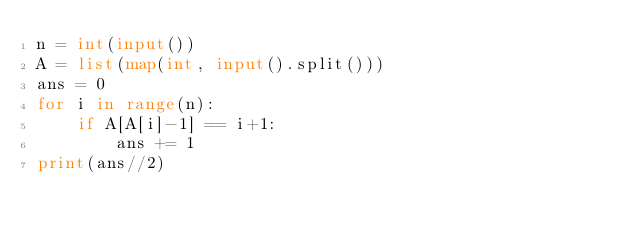<code> <loc_0><loc_0><loc_500><loc_500><_Python_>n = int(input())
A = list(map(int, input().split()))
ans = 0
for i in range(n):
    if A[A[i]-1] == i+1:
        ans += 1
print(ans//2)
</code> 